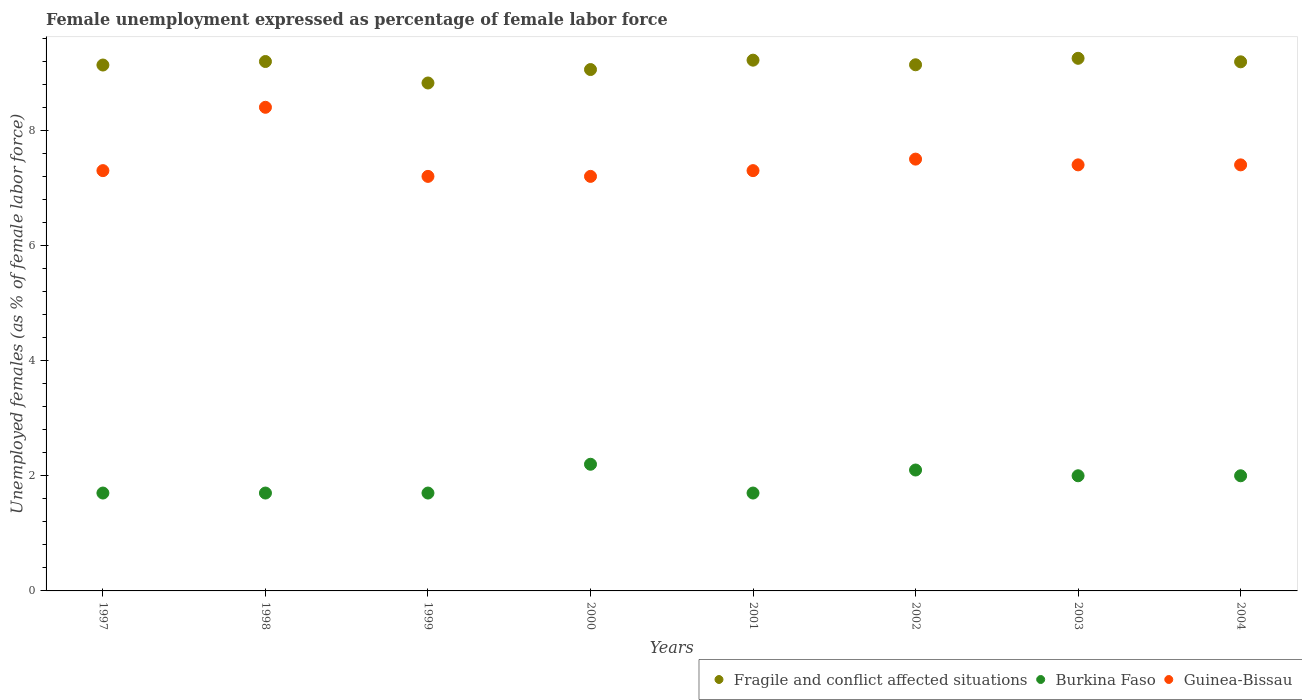What is the unemployment in females in in Fragile and conflict affected situations in 2001?
Your response must be concise. 9.22. Across all years, what is the maximum unemployment in females in in Burkina Faso?
Give a very brief answer. 2.2. Across all years, what is the minimum unemployment in females in in Guinea-Bissau?
Make the answer very short. 7.2. In which year was the unemployment in females in in Burkina Faso maximum?
Offer a terse response. 2000. What is the total unemployment in females in in Fragile and conflict affected situations in the graph?
Make the answer very short. 73. What is the difference between the unemployment in females in in Fragile and conflict affected situations in 2001 and that in 2004?
Your response must be concise. 0.03. What is the difference between the unemployment in females in in Burkina Faso in 1998 and the unemployment in females in in Guinea-Bissau in 2004?
Provide a succinct answer. -5.7. What is the average unemployment in females in in Burkina Faso per year?
Your answer should be very brief. 1.89. In the year 1998, what is the difference between the unemployment in females in in Burkina Faso and unemployment in females in in Fragile and conflict affected situations?
Ensure brevity in your answer.  -7.5. In how many years, is the unemployment in females in in Fragile and conflict affected situations greater than 2.4 %?
Your answer should be very brief. 8. What is the ratio of the unemployment in females in in Burkina Faso in 2000 to that in 2002?
Provide a succinct answer. 1.05. Is the unemployment in females in in Burkina Faso in 1998 less than that in 2001?
Give a very brief answer. No. Is the difference between the unemployment in females in in Burkina Faso in 2000 and 2002 greater than the difference between the unemployment in females in in Fragile and conflict affected situations in 2000 and 2002?
Your answer should be compact. Yes. What is the difference between the highest and the second highest unemployment in females in in Burkina Faso?
Provide a succinct answer. 0.1. What is the difference between the highest and the lowest unemployment in females in in Fragile and conflict affected situations?
Ensure brevity in your answer.  0.43. In how many years, is the unemployment in females in in Guinea-Bissau greater than the average unemployment in females in in Guinea-Bissau taken over all years?
Offer a terse response. 2. Is the sum of the unemployment in females in in Burkina Faso in 1997 and 2001 greater than the maximum unemployment in females in in Guinea-Bissau across all years?
Provide a short and direct response. No. Is it the case that in every year, the sum of the unemployment in females in in Fragile and conflict affected situations and unemployment in females in in Burkina Faso  is greater than the unemployment in females in in Guinea-Bissau?
Your response must be concise. Yes. Does the unemployment in females in in Guinea-Bissau monotonically increase over the years?
Offer a terse response. No. Is the unemployment in females in in Guinea-Bissau strictly less than the unemployment in females in in Burkina Faso over the years?
Provide a short and direct response. No. What is the difference between two consecutive major ticks on the Y-axis?
Offer a very short reply. 2. Are the values on the major ticks of Y-axis written in scientific E-notation?
Your response must be concise. No. Does the graph contain grids?
Offer a very short reply. No. Where does the legend appear in the graph?
Give a very brief answer. Bottom right. What is the title of the graph?
Your answer should be very brief. Female unemployment expressed as percentage of female labor force. What is the label or title of the Y-axis?
Keep it short and to the point. Unemployed females (as % of female labor force). What is the Unemployed females (as % of female labor force) in Fragile and conflict affected situations in 1997?
Offer a very short reply. 9.13. What is the Unemployed females (as % of female labor force) in Burkina Faso in 1997?
Offer a terse response. 1.7. What is the Unemployed females (as % of female labor force) of Guinea-Bissau in 1997?
Offer a terse response. 7.3. What is the Unemployed females (as % of female labor force) in Fragile and conflict affected situations in 1998?
Your answer should be compact. 9.2. What is the Unemployed females (as % of female labor force) in Burkina Faso in 1998?
Your response must be concise. 1.7. What is the Unemployed females (as % of female labor force) in Guinea-Bissau in 1998?
Your answer should be very brief. 8.4. What is the Unemployed females (as % of female labor force) in Fragile and conflict affected situations in 1999?
Your response must be concise. 8.82. What is the Unemployed females (as % of female labor force) of Burkina Faso in 1999?
Your answer should be very brief. 1.7. What is the Unemployed females (as % of female labor force) of Guinea-Bissau in 1999?
Provide a succinct answer. 7.2. What is the Unemployed females (as % of female labor force) in Fragile and conflict affected situations in 2000?
Make the answer very short. 9.06. What is the Unemployed females (as % of female labor force) in Burkina Faso in 2000?
Give a very brief answer. 2.2. What is the Unemployed females (as % of female labor force) of Guinea-Bissau in 2000?
Your answer should be very brief. 7.2. What is the Unemployed females (as % of female labor force) of Fragile and conflict affected situations in 2001?
Offer a very short reply. 9.22. What is the Unemployed females (as % of female labor force) of Burkina Faso in 2001?
Offer a very short reply. 1.7. What is the Unemployed females (as % of female labor force) in Guinea-Bissau in 2001?
Provide a short and direct response. 7.3. What is the Unemployed females (as % of female labor force) in Fragile and conflict affected situations in 2002?
Make the answer very short. 9.14. What is the Unemployed females (as % of female labor force) in Burkina Faso in 2002?
Offer a very short reply. 2.1. What is the Unemployed females (as % of female labor force) of Fragile and conflict affected situations in 2003?
Make the answer very short. 9.25. What is the Unemployed females (as % of female labor force) of Burkina Faso in 2003?
Your response must be concise. 2. What is the Unemployed females (as % of female labor force) in Guinea-Bissau in 2003?
Provide a short and direct response. 7.4. What is the Unemployed females (as % of female labor force) of Fragile and conflict affected situations in 2004?
Give a very brief answer. 9.19. What is the Unemployed females (as % of female labor force) in Burkina Faso in 2004?
Provide a succinct answer. 2. What is the Unemployed females (as % of female labor force) in Guinea-Bissau in 2004?
Your response must be concise. 7.4. Across all years, what is the maximum Unemployed females (as % of female labor force) in Fragile and conflict affected situations?
Provide a succinct answer. 9.25. Across all years, what is the maximum Unemployed females (as % of female labor force) in Burkina Faso?
Your answer should be compact. 2.2. Across all years, what is the maximum Unemployed females (as % of female labor force) in Guinea-Bissau?
Make the answer very short. 8.4. Across all years, what is the minimum Unemployed females (as % of female labor force) in Fragile and conflict affected situations?
Offer a very short reply. 8.82. Across all years, what is the minimum Unemployed females (as % of female labor force) of Burkina Faso?
Offer a terse response. 1.7. Across all years, what is the minimum Unemployed females (as % of female labor force) in Guinea-Bissau?
Your response must be concise. 7.2. What is the total Unemployed females (as % of female labor force) of Fragile and conflict affected situations in the graph?
Your answer should be very brief. 73. What is the total Unemployed females (as % of female labor force) in Guinea-Bissau in the graph?
Keep it short and to the point. 59.7. What is the difference between the Unemployed females (as % of female labor force) of Fragile and conflict affected situations in 1997 and that in 1998?
Make the answer very short. -0.06. What is the difference between the Unemployed females (as % of female labor force) of Guinea-Bissau in 1997 and that in 1998?
Make the answer very short. -1.1. What is the difference between the Unemployed females (as % of female labor force) in Fragile and conflict affected situations in 1997 and that in 1999?
Your response must be concise. 0.31. What is the difference between the Unemployed females (as % of female labor force) of Guinea-Bissau in 1997 and that in 1999?
Your answer should be very brief. 0.1. What is the difference between the Unemployed females (as % of female labor force) of Fragile and conflict affected situations in 1997 and that in 2000?
Make the answer very short. 0.08. What is the difference between the Unemployed females (as % of female labor force) of Burkina Faso in 1997 and that in 2000?
Offer a terse response. -0.5. What is the difference between the Unemployed females (as % of female labor force) of Fragile and conflict affected situations in 1997 and that in 2001?
Provide a succinct answer. -0.08. What is the difference between the Unemployed females (as % of female labor force) in Guinea-Bissau in 1997 and that in 2001?
Your response must be concise. 0. What is the difference between the Unemployed females (as % of female labor force) of Fragile and conflict affected situations in 1997 and that in 2002?
Your answer should be compact. -0. What is the difference between the Unemployed females (as % of female labor force) in Burkina Faso in 1997 and that in 2002?
Keep it short and to the point. -0.4. What is the difference between the Unemployed females (as % of female labor force) of Fragile and conflict affected situations in 1997 and that in 2003?
Offer a very short reply. -0.12. What is the difference between the Unemployed females (as % of female labor force) in Fragile and conflict affected situations in 1997 and that in 2004?
Ensure brevity in your answer.  -0.06. What is the difference between the Unemployed females (as % of female labor force) in Guinea-Bissau in 1997 and that in 2004?
Give a very brief answer. -0.1. What is the difference between the Unemployed females (as % of female labor force) in Fragile and conflict affected situations in 1998 and that in 1999?
Keep it short and to the point. 0.37. What is the difference between the Unemployed females (as % of female labor force) of Guinea-Bissau in 1998 and that in 1999?
Ensure brevity in your answer.  1.2. What is the difference between the Unemployed females (as % of female labor force) in Fragile and conflict affected situations in 1998 and that in 2000?
Give a very brief answer. 0.14. What is the difference between the Unemployed females (as % of female labor force) in Guinea-Bissau in 1998 and that in 2000?
Ensure brevity in your answer.  1.2. What is the difference between the Unemployed females (as % of female labor force) of Fragile and conflict affected situations in 1998 and that in 2001?
Give a very brief answer. -0.02. What is the difference between the Unemployed females (as % of female labor force) of Guinea-Bissau in 1998 and that in 2001?
Give a very brief answer. 1.1. What is the difference between the Unemployed females (as % of female labor force) in Fragile and conflict affected situations in 1998 and that in 2002?
Keep it short and to the point. 0.06. What is the difference between the Unemployed females (as % of female labor force) of Burkina Faso in 1998 and that in 2002?
Make the answer very short. -0.4. What is the difference between the Unemployed females (as % of female labor force) in Fragile and conflict affected situations in 1998 and that in 2003?
Ensure brevity in your answer.  -0.06. What is the difference between the Unemployed females (as % of female labor force) in Guinea-Bissau in 1998 and that in 2003?
Provide a succinct answer. 1. What is the difference between the Unemployed females (as % of female labor force) of Fragile and conflict affected situations in 1998 and that in 2004?
Give a very brief answer. 0.01. What is the difference between the Unemployed females (as % of female labor force) of Guinea-Bissau in 1998 and that in 2004?
Provide a short and direct response. 1. What is the difference between the Unemployed females (as % of female labor force) in Fragile and conflict affected situations in 1999 and that in 2000?
Your answer should be compact. -0.23. What is the difference between the Unemployed females (as % of female labor force) of Burkina Faso in 1999 and that in 2000?
Your answer should be compact. -0.5. What is the difference between the Unemployed females (as % of female labor force) in Guinea-Bissau in 1999 and that in 2000?
Offer a very short reply. 0. What is the difference between the Unemployed females (as % of female labor force) of Fragile and conflict affected situations in 1999 and that in 2001?
Your answer should be compact. -0.4. What is the difference between the Unemployed females (as % of female labor force) in Burkina Faso in 1999 and that in 2001?
Provide a succinct answer. 0. What is the difference between the Unemployed females (as % of female labor force) of Fragile and conflict affected situations in 1999 and that in 2002?
Give a very brief answer. -0.32. What is the difference between the Unemployed females (as % of female labor force) of Burkina Faso in 1999 and that in 2002?
Give a very brief answer. -0.4. What is the difference between the Unemployed females (as % of female labor force) of Fragile and conflict affected situations in 1999 and that in 2003?
Offer a terse response. -0.43. What is the difference between the Unemployed females (as % of female labor force) in Fragile and conflict affected situations in 1999 and that in 2004?
Offer a very short reply. -0.37. What is the difference between the Unemployed females (as % of female labor force) of Fragile and conflict affected situations in 2000 and that in 2001?
Provide a short and direct response. -0.16. What is the difference between the Unemployed females (as % of female labor force) in Fragile and conflict affected situations in 2000 and that in 2002?
Keep it short and to the point. -0.08. What is the difference between the Unemployed females (as % of female labor force) in Burkina Faso in 2000 and that in 2002?
Provide a succinct answer. 0.1. What is the difference between the Unemployed females (as % of female labor force) of Fragile and conflict affected situations in 2000 and that in 2003?
Offer a very short reply. -0.2. What is the difference between the Unemployed females (as % of female labor force) of Burkina Faso in 2000 and that in 2003?
Make the answer very short. 0.2. What is the difference between the Unemployed females (as % of female labor force) in Fragile and conflict affected situations in 2000 and that in 2004?
Offer a terse response. -0.13. What is the difference between the Unemployed females (as % of female labor force) of Burkina Faso in 2000 and that in 2004?
Make the answer very short. 0.2. What is the difference between the Unemployed females (as % of female labor force) in Fragile and conflict affected situations in 2001 and that in 2002?
Offer a terse response. 0.08. What is the difference between the Unemployed females (as % of female labor force) in Burkina Faso in 2001 and that in 2002?
Ensure brevity in your answer.  -0.4. What is the difference between the Unemployed females (as % of female labor force) of Fragile and conflict affected situations in 2001 and that in 2003?
Ensure brevity in your answer.  -0.03. What is the difference between the Unemployed females (as % of female labor force) in Fragile and conflict affected situations in 2001 and that in 2004?
Offer a very short reply. 0.03. What is the difference between the Unemployed females (as % of female labor force) of Burkina Faso in 2001 and that in 2004?
Ensure brevity in your answer.  -0.3. What is the difference between the Unemployed females (as % of female labor force) of Fragile and conflict affected situations in 2002 and that in 2003?
Give a very brief answer. -0.11. What is the difference between the Unemployed females (as % of female labor force) of Guinea-Bissau in 2002 and that in 2003?
Your answer should be very brief. 0.1. What is the difference between the Unemployed females (as % of female labor force) in Fragile and conflict affected situations in 2002 and that in 2004?
Make the answer very short. -0.05. What is the difference between the Unemployed females (as % of female labor force) in Fragile and conflict affected situations in 2003 and that in 2004?
Your response must be concise. 0.06. What is the difference between the Unemployed females (as % of female labor force) of Burkina Faso in 2003 and that in 2004?
Offer a terse response. 0. What is the difference between the Unemployed females (as % of female labor force) of Fragile and conflict affected situations in 1997 and the Unemployed females (as % of female labor force) of Burkina Faso in 1998?
Your answer should be compact. 7.43. What is the difference between the Unemployed females (as % of female labor force) of Fragile and conflict affected situations in 1997 and the Unemployed females (as % of female labor force) of Guinea-Bissau in 1998?
Provide a succinct answer. 0.73. What is the difference between the Unemployed females (as % of female labor force) in Fragile and conflict affected situations in 1997 and the Unemployed females (as % of female labor force) in Burkina Faso in 1999?
Offer a terse response. 7.43. What is the difference between the Unemployed females (as % of female labor force) of Fragile and conflict affected situations in 1997 and the Unemployed females (as % of female labor force) of Guinea-Bissau in 1999?
Provide a short and direct response. 1.93. What is the difference between the Unemployed females (as % of female labor force) of Burkina Faso in 1997 and the Unemployed females (as % of female labor force) of Guinea-Bissau in 1999?
Make the answer very short. -5.5. What is the difference between the Unemployed females (as % of female labor force) in Fragile and conflict affected situations in 1997 and the Unemployed females (as % of female labor force) in Burkina Faso in 2000?
Ensure brevity in your answer.  6.93. What is the difference between the Unemployed females (as % of female labor force) of Fragile and conflict affected situations in 1997 and the Unemployed females (as % of female labor force) of Guinea-Bissau in 2000?
Your answer should be very brief. 1.93. What is the difference between the Unemployed females (as % of female labor force) of Burkina Faso in 1997 and the Unemployed females (as % of female labor force) of Guinea-Bissau in 2000?
Your answer should be very brief. -5.5. What is the difference between the Unemployed females (as % of female labor force) in Fragile and conflict affected situations in 1997 and the Unemployed females (as % of female labor force) in Burkina Faso in 2001?
Give a very brief answer. 7.43. What is the difference between the Unemployed females (as % of female labor force) of Fragile and conflict affected situations in 1997 and the Unemployed females (as % of female labor force) of Guinea-Bissau in 2001?
Ensure brevity in your answer.  1.83. What is the difference between the Unemployed females (as % of female labor force) of Burkina Faso in 1997 and the Unemployed females (as % of female labor force) of Guinea-Bissau in 2001?
Ensure brevity in your answer.  -5.6. What is the difference between the Unemployed females (as % of female labor force) in Fragile and conflict affected situations in 1997 and the Unemployed females (as % of female labor force) in Burkina Faso in 2002?
Your response must be concise. 7.03. What is the difference between the Unemployed females (as % of female labor force) of Fragile and conflict affected situations in 1997 and the Unemployed females (as % of female labor force) of Guinea-Bissau in 2002?
Offer a terse response. 1.63. What is the difference between the Unemployed females (as % of female labor force) in Burkina Faso in 1997 and the Unemployed females (as % of female labor force) in Guinea-Bissau in 2002?
Offer a very short reply. -5.8. What is the difference between the Unemployed females (as % of female labor force) of Fragile and conflict affected situations in 1997 and the Unemployed females (as % of female labor force) of Burkina Faso in 2003?
Your answer should be very brief. 7.13. What is the difference between the Unemployed females (as % of female labor force) in Fragile and conflict affected situations in 1997 and the Unemployed females (as % of female labor force) in Guinea-Bissau in 2003?
Keep it short and to the point. 1.73. What is the difference between the Unemployed females (as % of female labor force) in Fragile and conflict affected situations in 1997 and the Unemployed females (as % of female labor force) in Burkina Faso in 2004?
Offer a terse response. 7.13. What is the difference between the Unemployed females (as % of female labor force) in Fragile and conflict affected situations in 1997 and the Unemployed females (as % of female labor force) in Guinea-Bissau in 2004?
Provide a succinct answer. 1.73. What is the difference between the Unemployed females (as % of female labor force) of Fragile and conflict affected situations in 1998 and the Unemployed females (as % of female labor force) of Burkina Faso in 1999?
Make the answer very short. 7.5. What is the difference between the Unemployed females (as % of female labor force) in Fragile and conflict affected situations in 1998 and the Unemployed females (as % of female labor force) in Guinea-Bissau in 1999?
Provide a short and direct response. 2. What is the difference between the Unemployed females (as % of female labor force) of Fragile and conflict affected situations in 1998 and the Unemployed females (as % of female labor force) of Burkina Faso in 2000?
Provide a succinct answer. 7. What is the difference between the Unemployed females (as % of female labor force) of Fragile and conflict affected situations in 1998 and the Unemployed females (as % of female labor force) of Guinea-Bissau in 2000?
Your response must be concise. 2. What is the difference between the Unemployed females (as % of female labor force) of Burkina Faso in 1998 and the Unemployed females (as % of female labor force) of Guinea-Bissau in 2000?
Give a very brief answer. -5.5. What is the difference between the Unemployed females (as % of female labor force) in Fragile and conflict affected situations in 1998 and the Unemployed females (as % of female labor force) in Burkina Faso in 2001?
Provide a short and direct response. 7.5. What is the difference between the Unemployed females (as % of female labor force) of Fragile and conflict affected situations in 1998 and the Unemployed females (as % of female labor force) of Guinea-Bissau in 2001?
Offer a very short reply. 1.9. What is the difference between the Unemployed females (as % of female labor force) in Burkina Faso in 1998 and the Unemployed females (as % of female labor force) in Guinea-Bissau in 2001?
Your answer should be very brief. -5.6. What is the difference between the Unemployed females (as % of female labor force) in Fragile and conflict affected situations in 1998 and the Unemployed females (as % of female labor force) in Burkina Faso in 2002?
Your response must be concise. 7.1. What is the difference between the Unemployed females (as % of female labor force) of Fragile and conflict affected situations in 1998 and the Unemployed females (as % of female labor force) of Guinea-Bissau in 2002?
Your answer should be compact. 1.7. What is the difference between the Unemployed females (as % of female labor force) in Fragile and conflict affected situations in 1998 and the Unemployed females (as % of female labor force) in Burkina Faso in 2003?
Ensure brevity in your answer.  7.2. What is the difference between the Unemployed females (as % of female labor force) of Fragile and conflict affected situations in 1998 and the Unemployed females (as % of female labor force) of Guinea-Bissau in 2003?
Offer a terse response. 1.8. What is the difference between the Unemployed females (as % of female labor force) of Fragile and conflict affected situations in 1998 and the Unemployed females (as % of female labor force) of Burkina Faso in 2004?
Your answer should be very brief. 7.2. What is the difference between the Unemployed females (as % of female labor force) of Fragile and conflict affected situations in 1998 and the Unemployed females (as % of female labor force) of Guinea-Bissau in 2004?
Provide a short and direct response. 1.8. What is the difference between the Unemployed females (as % of female labor force) in Burkina Faso in 1998 and the Unemployed females (as % of female labor force) in Guinea-Bissau in 2004?
Ensure brevity in your answer.  -5.7. What is the difference between the Unemployed females (as % of female labor force) of Fragile and conflict affected situations in 1999 and the Unemployed females (as % of female labor force) of Burkina Faso in 2000?
Ensure brevity in your answer.  6.62. What is the difference between the Unemployed females (as % of female labor force) in Fragile and conflict affected situations in 1999 and the Unemployed females (as % of female labor force) in Guinea-Bissau in 2000?
Your answer should be very brief. 1.62. What is the difference between the Unemployed females (as % of female labor force) of Fragile and conflict affected situations in 1999 and the Unemployed females (as % of female labor force) of Burkina Faso in 2001?
Provide a succinct answer. 7.12. What is the difference between the Unemployed females (as % of female labor force) of Fragile and conflict affected situations in 1999 and the Unemployed females (as % of female labor force) of Guinea-Bissau in 2001?
Give a very brief answer. 1.52. What is the difference between the Unemployed females (as % of female labor force) in Burkina Faso in 1999 and the Unemployed females (as % of female labor force) in Guinea-Bissau in 2001?
Provide a succinct answer. -5.6. What is the difference between the Unemployed females (as % of female labor force) of Fragile and conflict affected situations in 1999 and the Unemployed females (as % of female labor force) of Burkina Faso in 2002?
Provide a short and direct response. 6.72. What is the difference between the Unemployed females (as % of female labor force) in Fragile and conflict affected situations in 1999 and the Unemployed females (as % of female labor force) in Guinea-Bissau in 2002?
Provide a short and direct response. 1.32. What is the difference between the Unemployed females (as % of female labor force) in Burkina Faso in 1999 and the Unemployed females (as % of female labor force) in Guinea-Bissau in 2002?
Give a very brief answer. -5.8. What is the difference between the Unemployed females (as % of female labor force) in Fragile and conflict affected situations in 1999 and the Unemployed females (as % of female labor force) in Burkina Faso in 2003?
Ensure brevity in your answer.  6.82. What is the difference between the Unemployed females (as % of female labor force) of Fragile and conflict affected situations in 1999 and the Unemployed females (as % of female labor force) of Guinea-Bissau in 2003?
Give a very brief answer. 1.42. What is the difference between the Unemployed females (as % of female labor force) of Burkina Faso in 1999 and the Unemployed females (as % of female labor force) of Guinea-Bissau in 2003?
Your answer should be very brief. -5.7. What is the difference between the Unemployed females (as % of female labor force) in Fragile and conflict affected situations in 1999 and the Unemployed females (as % of female labor force) in Burkina Faso in 2004?
Your answer should be very brief. 6.82. What is the difference between the Unemployed females (as % of female labor force) of Fragile and conflict affected situations in 1999 and the Unemployed females (as % of female labor force) of Guinea-Bissau in 2004?
Provide a succinct answer. 1.42. What is the difference between the Unemployed females (as % of female labor force) of Fragile and conflict affected situations in 2000 and the Unemployed females (as % of female labor force) of Burkina Faso in 2001?
Keep it short and to the point. 7.36. What is the difference between the Unemployed females (as % of female labor force) in Fragile and conflict affected situations in 2000 and the Unemployed females (as % of female labor force) in Guinea-Bissau in 2001?
Give a very brief answer. 1.76. What is the difference between the Unemployed females (as % of female labor force) of Fragile and conflict affected situations in 2000 and the Unemployed females (as % of female labor force) of Burkina Faso in 2002?
Ensure brevity in your answer.  6.96. What is the difference between the Unemployed females (as % of female labor force) of Fragile and conflict affected situations in 2000 and the Unemployed females (as % of female labor force) of Guinea-Bissau in 2002?
Your answer should be compact. 1.56. What is the difference between the Unemployed females (as % of female labor force) of Burkina Faso in 2000 and the Unemployed females (as % of female labor force) of Guinea-Bissau in 2002?
Offer a terse response. -5.3. What is the difference between the Unemployed females (as % of female labor force) in Fragile and conflict affected situations in 2000 and the Unemployed females (as % of female labor force) in Burkina Faso in 2003?
Provide a short and direct response. 7.06. What is the difference between the Unemployed females (as % of female labor force) of Fragile and conflict affected situations in 2000 and the Unemployed females (as % of female labor force) of Guinea-Bissau in 2003?
Keep it short and to the point. 1.66. What is the difference between the Unemployed females (as % of female labor force) of Fragile and conflict affected situations in 2000 and the Unemployed females (as % of female labor force) of Burkina Faso in 2004?
Your answer should be very brief. 7.06. What is the difference between the Unemployed females (as % of female labor force) of Fragile and conflict affected situations in 2000 and the Unemployed females (as % of female labor force) of Guinea-Bissau in 2004?
Ensure brevity in your answer.  1.66. What is the difference between the Unemployed females (as % of female labor force) of Fragile and conflict affected situations in 2001 and the Unemployed females (as % of female labor force) of Burkina Faso in 2002?
Your answer should be compact. 7.12. What is the difference between the Unemployed females (as % of female labor force) of Fragile and conflict affected situations in 2001 and the Unemployed females (as % of female labor force) of Guinea-Bissau in 2002?
Provide a short and direct response. 1.72. What is the difference between the Unemployed females (as % of female labor force) in Burkina Faso in 2001 and the Unemployed females (as % of female labor force) in Guinea-Bissau in 2002?
Provide a succinct answer. -5.8. What is the difference between the Unemployed females (as % of female labor force) of Fragile and conflict affected situations in 2001 and the Unemployed females (as % of female labor force) of Burkina Faso in 2003?
Ensure brevity in your answer.  7.22. What is the difference between the Unemployed females (as % of female labor force) of Fragile and conflict affected situations in 2001 and the Unemployed females (as % of female labor force) of Guinea-Bissau in 2003?
Make the answer very short. 1.82. What is the difference between the Unemployed females (as % of female labor force) of Burkina Faso in 2001 and the Unemployed females (as % of female labor force) of Guinea-Bissau in 2003?
Give a very brief answer. -5.7. What is the difference between the Unemployed females (as % of female labor force) of Fragile and conflict affected situations in 2001 and the Unemployed females (as % of female labor force) of Burkina Faso in 2004?
Your answer should be very brief. 7.22. What is the difference between the Unemployed females (as % of female labor force) in Fragile and conflict affected situations in 2001 and the Unemployed females (as % of female labor force) in Guinea-Bissau in 2004?
Offer a terse response. 1.82. What is the difference between the Unemployed females (as % of female labor force) in Burkina Faso in 2001 and the Unemployed females (as % of female labor force) in Guinea-Bissau in 2004?
Your response must be concise. -5.7. What is the difference between the Unemployed females (as % of female labor force) of Fragile and conflict affected situations in 2002 and the Unemployed females (as % of female labor force) of Burkina Faso in 2003?
Make the answer very short. 7.14. What is the difference between the Unemployed females (as % of female labor force) in Fragile and conflict affected situations in 2002 and the Unemployed females (as % of female labor force) in Guinea-Bissau in 2003?
Your answer should be very brief. 1.74. What is the difference between the Unemployed females (as % of female labor force) in Burkina Faso in 2002 and the Unemployed females (as % of female labor force) in Guinea-Bissau in 2003?
Your response must be concise. -5.3. What is the difference between the Unemployed females (as % of female labor force) in Fragile and conflict affected situations in 2002 and the Unemployed females (as % of female labor force) in Burkina Faso in 2004?
Provide a short and direct response. 7.14. What is the difference between the Unemployed females (as % of female labor force) in Fragile and conflict affected situations in 2002 and the Unemployed females (as % of female labor force) in Guinea-Bissau in 2004?
Make the answer very short. 1.74. What is the difference between the Unemployed females (as % of female labor force) in Burkina Faso in 2002 and the Unemployed females (as % of female labor force) in Guinea-Bissau in 2004?
Provide a succinct answer. -5.3. What is the difference between the Unemployed females (as % of female labor force) in Fragile and conflict affected situations in 2003 and the Unemployed females (as % of female labor force) in Burkina Faso in 2004?
Provide a succinct answer. 7.25. What is the difference between the Unemployed females (as % of female labor force) of Fragile and conflict affected situations in 2003 and the Unemployed females (as % of female labor force) of Guinea-Bissau in 2004?
Ensure brevity in your answer.  1.85. What is the average Unemployed females (as % of female labor force) in Fragile and conflict affected situations per year?
Give a very brief answer. 9.13. What is the average Unemployed females (as % of female labor force) in Burkina Faso per year?
Your answer should be very brief. 1.89. What is the average Unemployed females (as % of female labor force) in Guinea-Bissau per year?
Keep it short and to the point. 7.46. In the year 1997, what is the difference between the Unemployed females (as % of female labor force) in Fragile and conflict affected situations and Unemployed females (as % of female labor force) in Burkina Faso?
Your response must be concise. 7.43. In the year 1997, what is the difference between the Unemployed females (as % of female labor force) of Fragile and conflict affected situations and Unemployed females (as % of female labor force) of Guinea-Bissau?
Provide a succinct answer. 1.83. In the year 1997, what is the difference between the Unemployed females (as % of female labor force) of Burkina Faso and Unemployed females (as % of female labor force) of Guinea-Bissau?
Your answer should be very brief. -5.6. In the year 1998, what is the difference between the Unemployed females (as % of female labor force) in Fragile and conflict affected situations and Unemployed females (as % of female labor force) in Burkina Faso?
Give a very brief answer. 7.5. In the year 1998, what is the difference between the Unemployed females (as % of female labor force) in Fragile and conflict affected situations and Unemployed females (as % of female labor force) in Guinea-Bissau?
Your answer should be very brief. 0.8. In the year 1998, what is the difference between the Unemployed females (as % of female labor force) of Burkina Faso and Unemployed females (as % of female labor force) of Guinea-Bissau?
Your answer should be very brief. -6.7. In the year 1999, what is the difference between the Unemployed females (as % of female labor force) in Fragile and conflict affected situations and Unemployed females (as % of female labor force) in Burkina Faso?
Provide a short and direct response. 7.12. In the year 1999, what is the difference between the Unemployed females (as % of female labor force) in Fragile and conflict affected situations and Unemployed females (as % of female labor force) in Guinea-Bissau?
Keep it short and to the point. 1.62. In the year 2000, what is the difference between the Unemployed females (as % of female labor force) of Fragile and conflict affected situations and Unemployed females (as % of female labor force) of Burkina Faso?
Provide a short and direct response. 6.86. In the year 2000, what is the difference between the Unemployed females (as % of female labor force) of Fragile and conflict affected situations and Unemployed females (as % of female labor force) of Guinea-Bissau?
Your answer should be compact. 1.86. In the year 2001, what is the difference between the Unemployed females (as % of female labor force) of Fragile and conflict affected situations and Unemployed females (as % of female labor force) of Burkina Faso?
Provide a succinct answer. 7.52. In the year 2001, what is the difference between the Unemployed females (as % of female labor force) of Fragile and conflict affected situations and Unemployed females (as % of female labor force) of Guinea-Bissau?
Make the answer very short. 1.92. In the year 2001, what is the difference between the Unemployed females (as % of female labor force) in Burkina Faso and Unemployed females (as % of female labor force) in Guinea-Bissau?
Offer a very short reply. -5.6. In the year 2002, what is the difference between the Unemployed females (as % of female labor force) in Fragile and conflict affected situations and Unemployed females (as % of female labor force) in Burkina Faso?
Provide a short and direct response. 7.04. In the year 2002, what is the difference between the Unemployed females (as % of female labor force) of Fragile and conflict affected situations and Unemployed females (as % of female labor force) of Guinea-Bissau?
Ensure brevity in your answer.  1.64. In the year 2002, what is the difference between the Unemployed females (as % of female labor force) in Burkina Faso and Unemployed females (as % of female labor force) in Guinea-Bissau?
Make the answer very short. -5.4. In the year 2003, what is the difference between the Unemployed females (as % of female labor force) in Fragile and conflict affected situations and Unemployed females (as % of female labor force) in Burkina Faso?
Keep it short and to the point. 7.25. In the year 2003, what is the difference between the Unemployed females (as % of female labor force) of Fragile and conflict affected situations and Unemployed females (as % of female labor force) of Guinea-Bissau?
Ensure brevity in your answer.  1.85. In the year 2004, what is the difference between the Unemployed females (as % of female labor force) of Fragile and conflict affected situations and Unemployed females (as % of female labor force) of Burkina Faso?
Your answer should be compact. 7.19. In the year 2004, what is the difference between the Unemployed females (as % of female labor force) of Fragile and conflict affected situations and Unemployed females (as % of female labor force) of Guinea-Bissau?
Provide a succinct answer. 1.79. What is the ratio of the Unemployed females (as % of female labor force) of Fragile and conflict affected situations in 1997 to that in 1998?
Offer a terse response. 0.99. What is the ratio of the Unemployed females (as % of female labor force) of Burkina Faso in 1997 to that in 1998?
Provide a short and direct response. 1. What is the ratio of the Unemployed females (as % of female labor force) of Guinea-Bissau in 1997 to that in 1998?
Give a very brief answer. 0.87. What is the ratio of the Unemployed females (as % of female labor force) of Fragile and conflict affected situations in 1997 to that in 1999?
Ensure brevity in your answer.  1.04. What is the ratio of the Unemployed females (as % of female labor force) in Guinea-Bissau in 1997 to that in 1999?
Make the answer very short. 1.01. What is the ratio of the Unemployed females (as % of female labor force) of Fragile and conflict affected situations in 1997 to that in 2000?
Your response must be concise. 1.01. What is the ratio of the Unemployed females (as % of female labor force) in Burkina Faso in 1997 to that in 2000?
Keep it short and to the point. 0.77. What is the ratio of the Unemployed females (as % of female labor force) of Guinea-Bissau in 1997 to that in 2000?
Your response must be concise. 1.01. What is the ratio of the Unemployed females (as % of female labor force) of Fragile and conflict affected situations in 1997 to that in 2001?
Provide a short and direct response. 0.99. What is the ratio of the Unemployed females (as % of female labor force) of Burkina Faso in 1997 to that in 2002?
Make the answer very short. 0.81. What is the ratio of the Unemployed females (as % of female labor force) of Guinea-Bissau in 1997 to that in 2002?
Your response must be concise. 0.97. What is the ratio of the Unemployed females (as % of female labor force) of Fragile and conflict affected situations in 1997 to that in 2003?
Provide a succinct answer. 0.99. What is the ratio of the Unemployed females (as % of female labor force) in Burkina Faso in 1997 to that in 2003?
Your answer should be very brief. 0.85. What is the ratio of the Unemployed females (as % of female labor force) in Guinea-Bissau in 1997 to that in 2003?
Give a very brief answer. 0.99. What is the ratio of the Unemployed females (as % of female labor force) in Fragile and conflict affected situations in 1997 to that in 2004?
Ensure brevity in your answer.  0.99. What is the ratio of the Unemployed females (as % of female labor force) in Guinea-Bissau in 1997 to that in 2004?
Give a very brief answer. 0.99. What is the ratio of the Unemployed females (as % of female labor force) of Fragile and conflict affected situations in 1998 to that in 1999?
Your answer should be very brief. 1.04. What is the ratio of the Unemployed females (as % of female labor force) in Burkina Faso in 1998 to that in 1999?
Offer a terse response. 1. What is the ratio of the Unemployed females (as % of female labor force) of Guinea-Bissau in 1998 to that in 1999?
Your answer should be very brief. 1.17. What is the ratio of the Unemployed females (as % of female labor force) in Fragile and conflict affected situations in 1998 to that in 2000?
Make the answer very short. 1.02. What is the ratio of the Unemployed females (as % of female labor force) in Burkina Faso in 1998 to that in 2000?
Give a very brief answer. 0.77. What is the ratio of the Unemployed females (as % of female labor force) of Guinea-Bissau in 1998 to that in 2001?
Offer a terse response. 1.15. What is the ratio of the Unemployed females (as % of female labor force) in Burkina Faso in 1998 to that in 2002?
Provide a short and direct response. 0.81. What is the ratio of the Unemployed females (as % of female labor force) in Guinea-Bissau in 1998 to that in 2002?
Ensure brevity in your answer.  1.12. What is the ratio of the Unemployed females (as % of female labor force) in Guinea-Bissau in 1998 to that in 2003?
Keep it short and to the point. 1.14. What is the ratio of the Unemployed females (as % of female labor force) in Burkina Faso in 1998 to that in 2004?
Your response must be concise. 0.85. What is the ratio of the Unemployed females (as % of female labor force) of Guinea-Bissau in 1998 to that in 2004?
Your answer should be compact. 1.14. What is the ratio of the Unemployed females (as % of female labor force) of Fragile and conflict affected situations in 1999 to that in 2000?
Offer a very short reply. 0.97. What is the ratio of the Unemployed females (as % of female labor force) in Burkina Faso in 1999 to that in 2000?
Make the answer very short. 0.77. What is the ratio of the Unemployed females (as % of female labor force) in Fragile and conflict affected situations in 1999 to that in 2001?
Ensure brevity in your answer.  0.96. What is the ratio of the Unemployed females (as % of female labor force) in Guinea-Bissau in 1999 to that in 2001?
Provide a succinct answer. 0.99. What is the ratio of the Unemployed females (as % of female labor force) of Fragile and conflict affected situations in 1999 to that in 2002?
Offer a terse response. 0.97. What is the ratio of the Unemployed females (as % of female labor force) in Burkina Faso in 1999 to that in 2002?
Your response must be concise. 0.81. What is the ratio of the Unemployed females (as % of female labor force) in Fragile and conflict affected situations in 1999 to that in 2003?
Keep it short and to the point. 0.95. What is the ratio of the Unemployed females (as % of female labor force) in Burkina Faso in 1999 to that in 2003?
Make the answer very short. 0.85. What is the ratio of the Unemployed females (as % of female labor force) in Burkina Faso in 1999 to that in 2004?
Your response must be concise. 0.85. What is the ratio of the Unemployed females (as % of female labor force) in Fragile and conflict affected situations in 2000 to that in 2001?
Make the answer very short. 0.98. What is the ratio of the Unemployed females (as % of female labor force) of Burkina Faso in 2000 to that in 2001?
Give a very brief answer. 1.29. What is the ratio of the Unemployed females (as % of female labor force) of Guinea-Bissau in 2000 to that in 2001?
Ensure brevity in your answer.  0.99. What is the ratio of the Unemployed females (as % of female labor force) in Fragile and conflict affected situations in 2000 to that in 2002?
Your response must be concise. 0.99. What is the ratio of the Unemployed females (as % of female labor force) of Burkina Faso in 2000 to that in 2002?
Provide a short and direct response. 1.05. What is the ratio of the Unemployed females (as % of female labor force) in Fragile and conflict affected situations in 2000 to that in 2003?
Your response must be concise. 0.98. What is the ratio of the Unemployed females (as % of female labor force) in Burkina Faso in 2000 to that in 2003?
Provide a succinct answer. 1.1. What is the ratio of the Unemployed females (as % of female labor force) in Guinea-Bissau in 2000 to that in 2003?
Provide a short and direct response. 0.97. What is the ratio of the Unemployed females (as % of female labor force) of Fragile and conflict affected situations in 2000 to that in 2004?
Keep it short and to the point. 0.99. What is the ratio of the Unemployed females (as % of female labor force) of Burkina Faso in 2000 to that in 2004?
Give a very brief answer. 1.1. What is the ratio of the Unemployed females (as % of female labor force) of Fragile and conflict affected situations in 2001 to that in 2002?
Provide a succinct answer. 1.01. What is the ratio of the Unemployed females (as % of female labor force) in Burkina Faso in 2001 to that in 2002?
Give a very brief answer. 0.81. What is the ratio of the Unemployed females (as % of female labor force) of Guinea-Bissau in 2001 to that in 2002?
Your answer should be compact. 0.97. What is the ratio of the Unemployed females (as % of female labor force) of Fragile and conflict affected situations in 2001 to that in 2003?
Provide a succinct answer. 1. What is the ratio of the Unemployed females (as % of female labor force) of Burkina Faso in 2001 to that in 2003?
Offer a very short reply. 0.85. What is the ratio of the Unemployed females (as % of female labor force) of Guinea-Bissau in 2001 to that in 2003?
Give a very brief answer. 0.99. What is the ratio of the Unemployed females (as % of female labor force) in Fragile and conflict affected situations in 2001 to that in 2004?
Provide a short and direct response. 1. What is the ratio of the Unemployed females (as % of female labor force) in Guinea-Bissau in 2001 to that in 2004?
Keep it short and to the point. 0.99. What is the ratio of the Unemployed females (as % of female labor force) of Fragile and conflict affected situations in 2002 to that in 2003?
Ensure brevity in your answer.  0.99. What is the ratio of the Unemployed females (as % of female labor force) of Burkina Faso in 2002 to that in 2003?
Offer a terse response. 1.05. What is the ratio of the Unemployed females (as % of female labor force) in Guinea-Bissau in 2002 to that in 2003?
Ensure brevity in your answer.  1.01. What is the ratio of the Unemployed females (as % of female labor force) of Burkina Faso in 2002 to that in 2004?
Your response must be concise. 1.05. What is the ratio of the Unemployed females (as % of female labor force) of Guinea-Bissau in 2002 to that in 2004?
Your response must be concise. 1.01. What is the ratio of the Unemployed females (as % of female labor force) in Fragile and conflict affected situations in 2003 to that in 2004?
Provide a succinct answer. 1.01. What is the ratio of the Unemployed females (as % of female labor force) of Burkina Faso in 2003 to that in 2004?
Your answer should be compact. 1. What is the ratio of the Unemployed females (as % of female labor force) of Guinea-Bissau in 2003 to that in 2004?
Provide a short and direct response. 1. What is the difference between the highest and the second highest Unemployed females (as % of female labor force) of Fragile and conflict affected situations?
Keep it short and to the point. 0.03. What is the difference between the highest and the lowest Unemployed females (as % of female labor force) in Fragile and conflict affected situations?
Offer a terse response. 0.43. What is the difference between the highest and the lowest Unemployed females (as % of female labor force) in Burkina Faso?
Keep it short and to the point. 0.5. What is the difference between the highest and the lowest Unemployed females (as % of female labor force) in Guinea-Bissau?
Your answer should be compact. 1.2. 